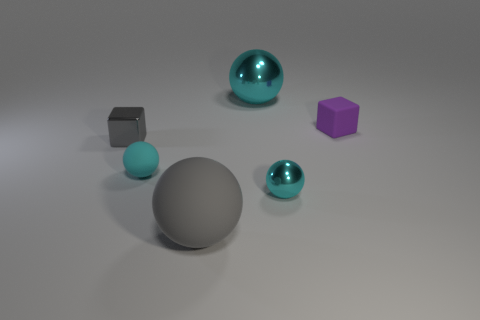Subtract all cyan blocks. How many cyan spheres are left? 3 Subtract all gray spheres. How many spheres are left? 3 Subtract 1 spheres. How many spheres are left? 3 Subtract all small metal balls. How many balls are left? 3 Subtract all yellow spheres. Subtract all cyan cubes. How many spheres are left? 4 Add 1 big yellow rubber cylinders. How many objects exist? 7 Subtract all spheres. How many objects are left? 2 Subtract 0 cyan cylinders. How many objects are left? 6 Subtract all gray objects. Subtract all purple objects. How many objects are left? 3 Add 6 large gray balls. How many large gray balls are left? 7 